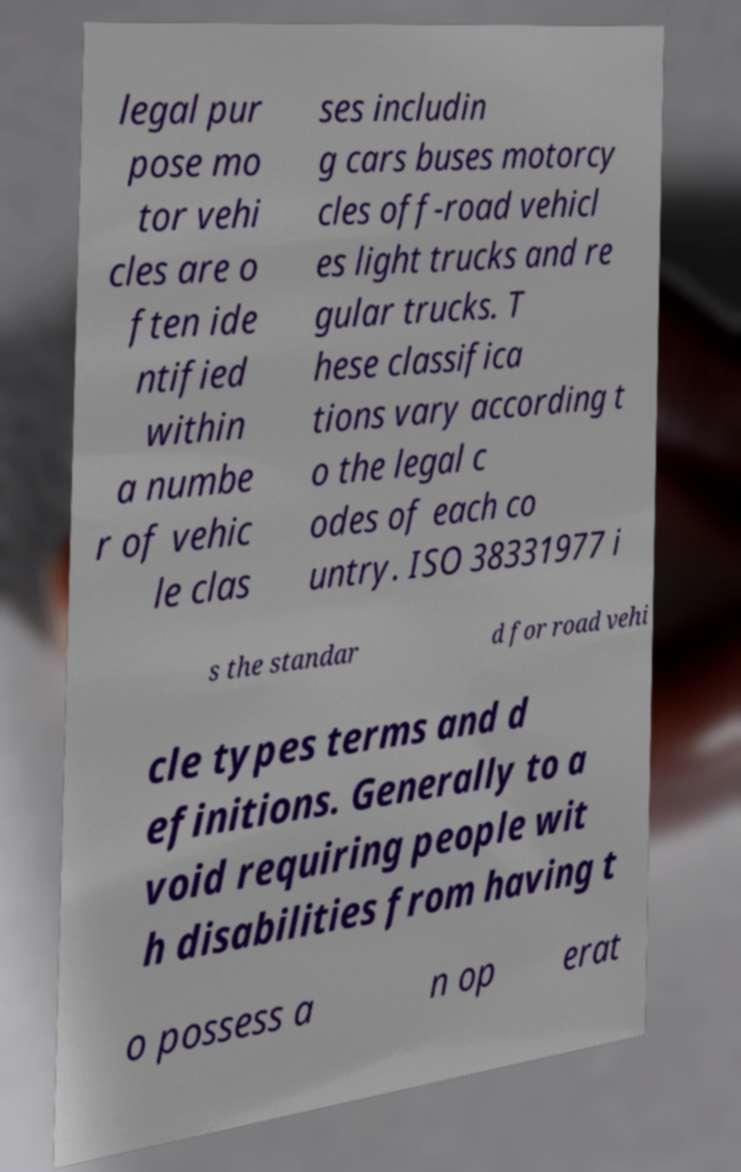Can you read and provide the text displayed in the image?This photo seems to have some interesting text. Can you extract and type it out for me? legal pur pose mo tor vehi cles are o ften ide ntified within a numbe r of vehic le clas ses includin g cars buses motorcy cles off-road vehicl es light trucks and re gular trucks. T hese classifica tions vary according t o the legal c odes of each co untry. ISO 38331977 i s the standar d for road vehi cle types terms and d efinitions. Generally to a void requiring people wit h disabilities from having t o possess a n op erat 